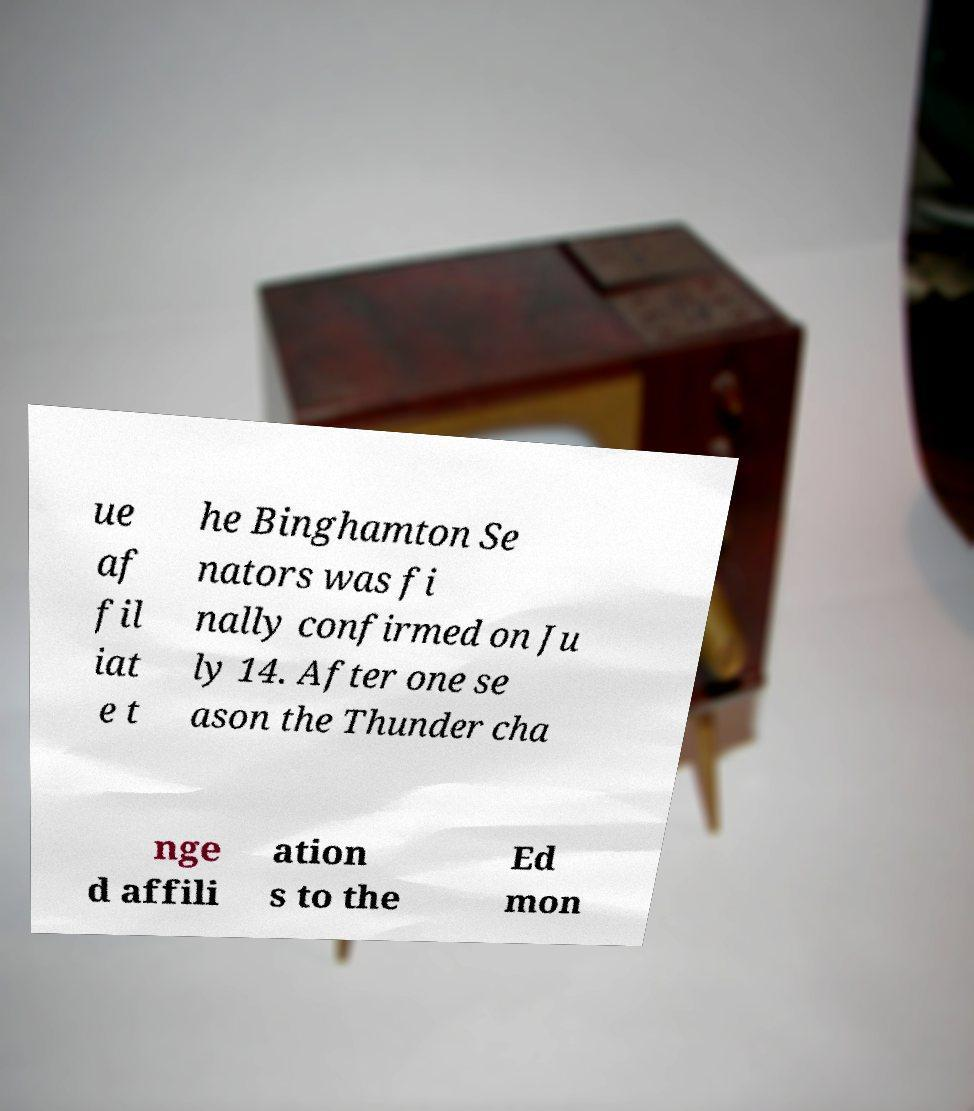Could you assist in decoding the text presented in this image and type it out clearly? ue af fil iat e t he Binghamton Se nators was fi nally confirmed on Ju ly 14. After one se ason the Thunder cha nge d affili ation s to the Ed mon 